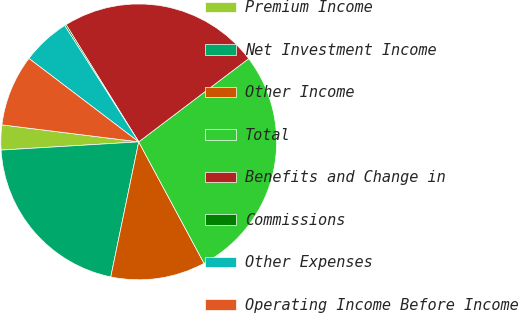Convert chart to OTSL. <chart><loc_0><loc_0><loc_500><loc_500><pie_chart><fcel>Premium Income<fcel>Net Investment Income<fcel>Other Income<fcel>Total<fcel>Benefits and Change in<fcel>Commissions<fcel>Other Expenses<fcel>Operating Income Before Income<nl><fcel>2.92%<fcel>20.8%<fcel>11.1%<fcel>27.46%<fcel>23.52%<fcel>0.19%<fcel>5.64%<fcel>8.37%<nl></chart> 